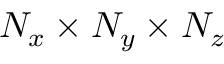Convert formula to latex. <formula><loc_0><loc_0><loc_500><loc_500>N _ { x } \times N _ { y } \times N _ { z }</formula> 